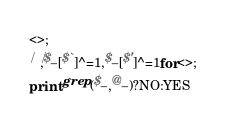<code> <loc_0><loc_0><loc_500><loc_500><_Perl_><>;
/ /,$_[$`]^=1,$_[$']^=1for<>;
print grep($_,@_)?NO:YES
</code> 